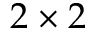<formula> <loc_0><loc_0><loc_500><loc_500>2 \times 2</formula> 